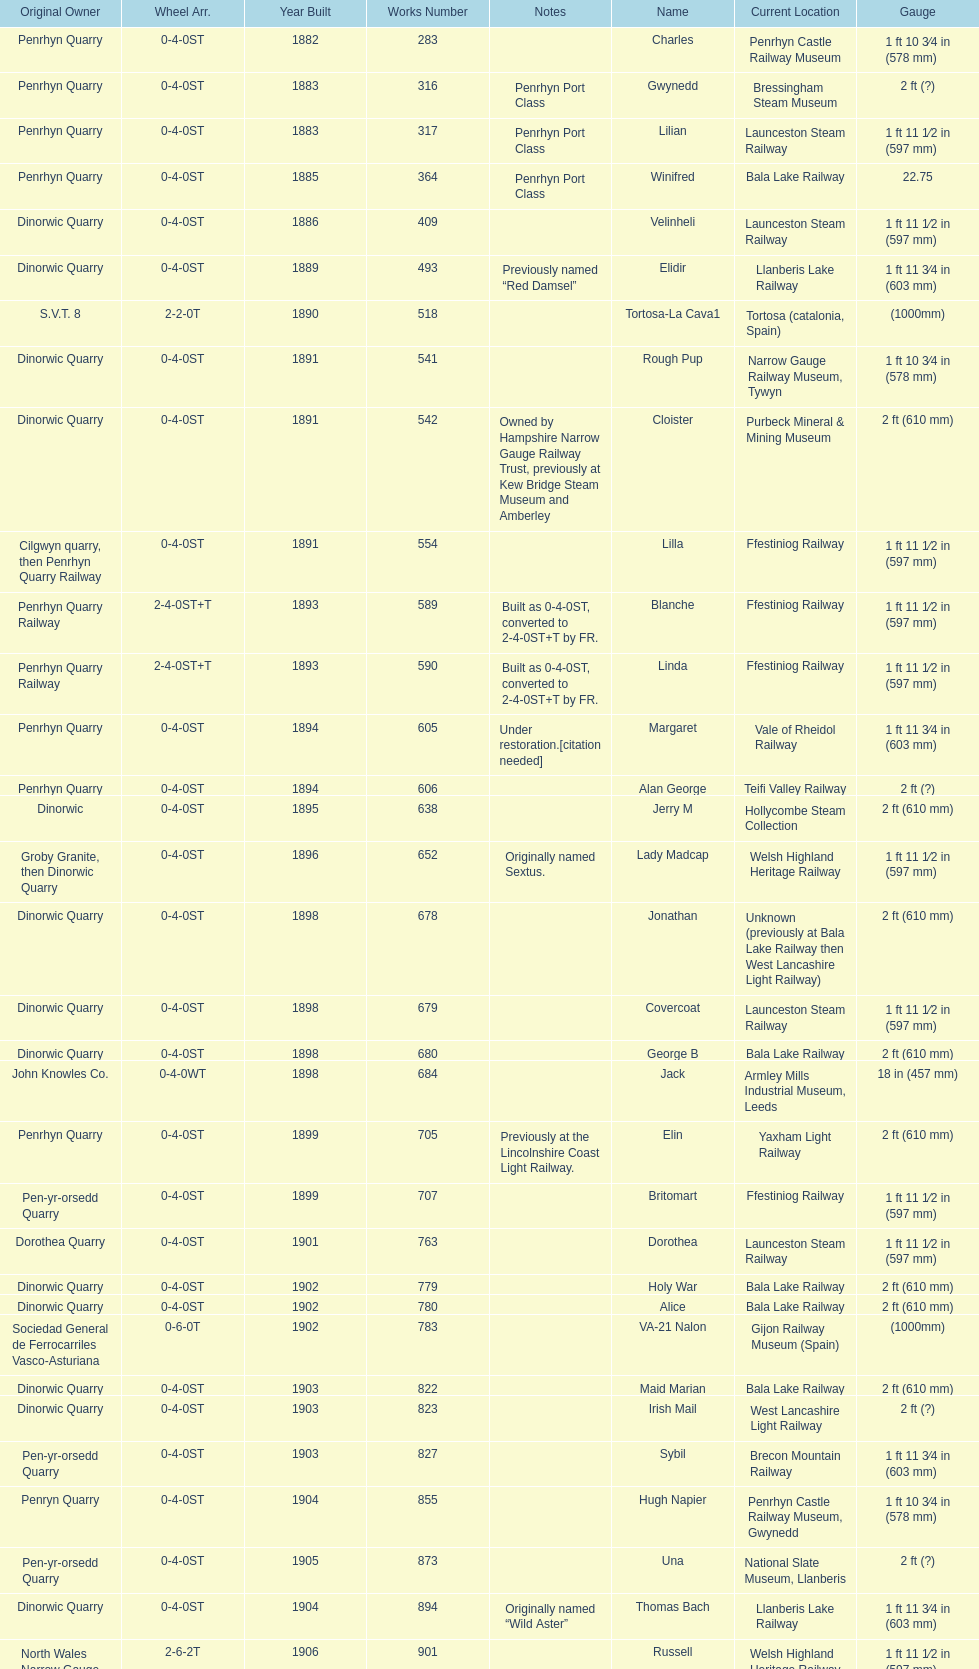What is the total number of preserved hunslet narrow gauge locomotives currently located in ffestiniog railway 554. 